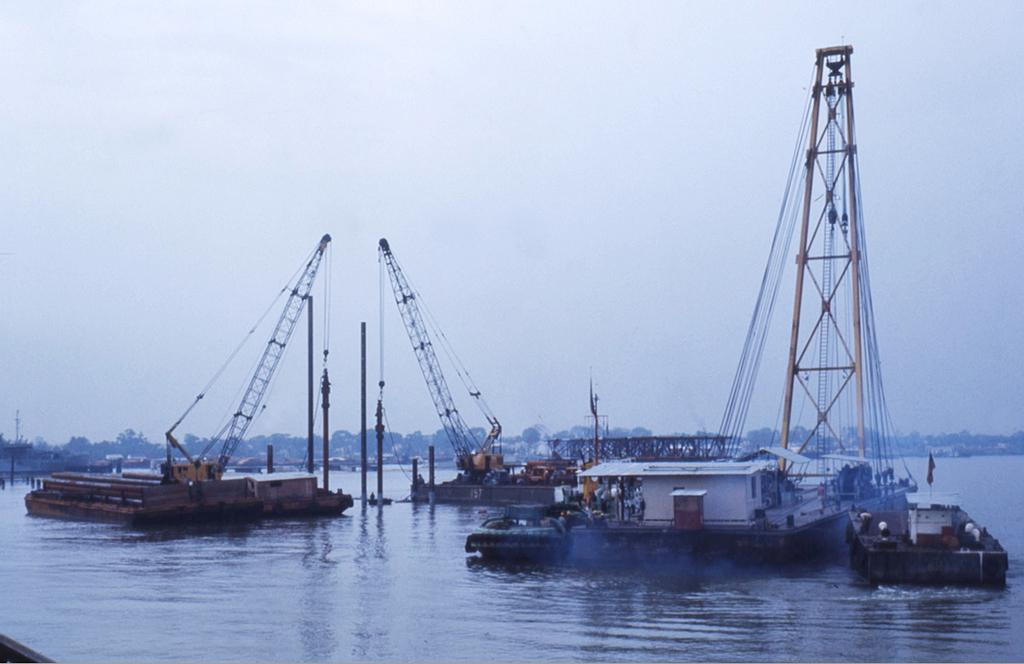What body of water is present in the image? There is a river in the image. What is on the river in the image? There are boats on the river. What can be seen on the boats in the image? There are cranes on the boats in the image. What type of vegetation is visible in the background of the image? There are trees in the background of the image. What is visible in the sky in the background of the image? The sky is visible in the background of the image. What type of pancake is being served on the boats in the image? There is no pancake present in the image; the boats have cranes on them. What type of power source is used by the cranes on the boats in the image? The image does not provide information about the power source for the cranes on the boats. 